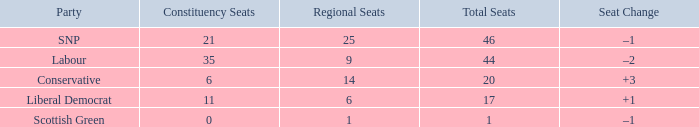How many regional seats were there with the SNP party and where the number of total seats was bigger than 46? 0.0. 